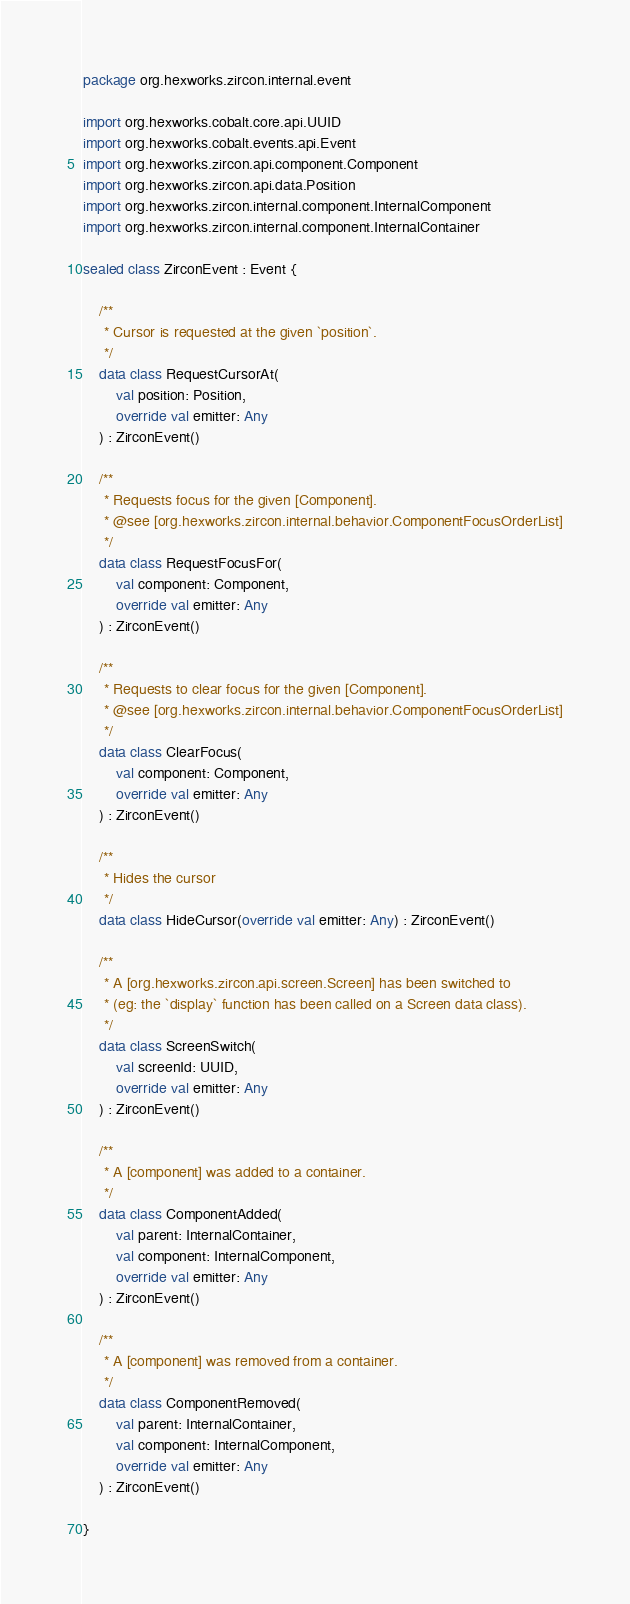Convert code to text. <code><loc_0><loc_0><loc_500><loc_500><_Kotlin_>package org.hexworks.zircon.internal.event

import org.hexworks.cobalt.core.api.UUID
import org.hexworks.cobalt.events.api.Event
import org.hexworks.zircon.api.component.Component
import org.hexworks.zircon.api.data.Position
import org.hexworks.zircon.internal.component.InternalComponent
import org.hexworks.zircon.internal.component.InternalContainer

sealed class ZirconEvent : Event {

    /**
     * Cursor is requested at the given `position`.
     */
    data class RequestCursorAt(
        val position: Position,
        override val emitter: Any
    ) : ZirconEvent()

    /**
     * Requests focus for the given [Component].
     * @see [org.hexworks.zircon.internal.behavior.ComponentFocusOrderList]
     */
    data class RequestFocusFor(
        val component: Component,
        override val emitter: Any
    ) : ZirconEvent()

    /**
     * Requests to clear focus for the given [Component].
     * @see [org.hexworks.zircon.internal.behavior.ComponentFocusOrderList]
     */
    data class ClearFocus(
        val component: Component,
        override val emitter: Any
    ) : ZirconEvent()

    /**
     * Hides the cursor
     */
    data class HideCursor(override val emitter: Any) : ZirconEvent()

    /**
     * A [org.hexworks.zircon.api.screen.Screen] has been switched to
     * (eg: the `display` function has been called on a Screen data class).
     */
    data class ScreenSwitch(
        val screenId: UUID,
        override val emitter: Any
    ) : ZirconEvent()

    /**
     * A [component] was added to a container.
     */
    data class ComponentAdded(
        val parent: InternalContainer,
        val component: InternalComponent,
        override val emitter: Any
    ) : ZirconEvent()

    /**
     * A [component] was removed from a container.
     */
    data class ComponentRemoved(
        val parent: InternalContainer,
        val component: InternalComponent,
        override val emitter: Any
    ) : ZirconEvent()

}
</code> 